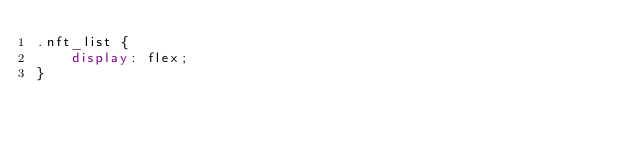<code> <loc_0><loc_0><loc_500><loc_500><_CSS_>.nft_list {
    display: flex;
}</code> 